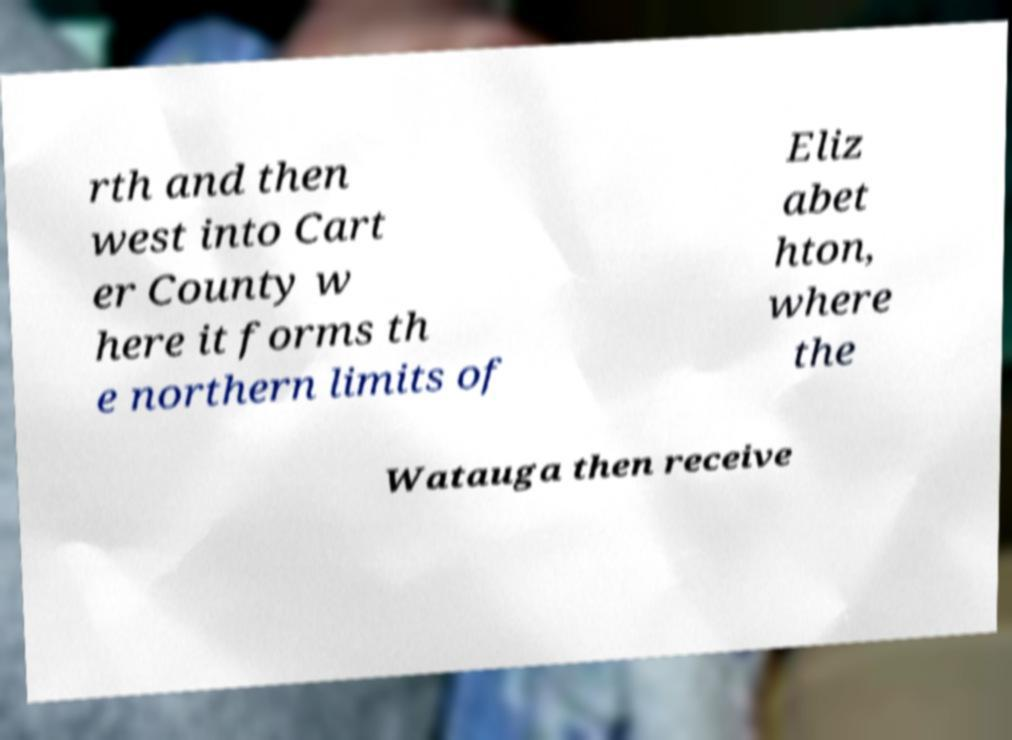Please read and relay the text visible in this image. What does it say? rth and then west into Cart er County w here it forms th e northern limits of Eliz abet hton, where the Watauga then receive 